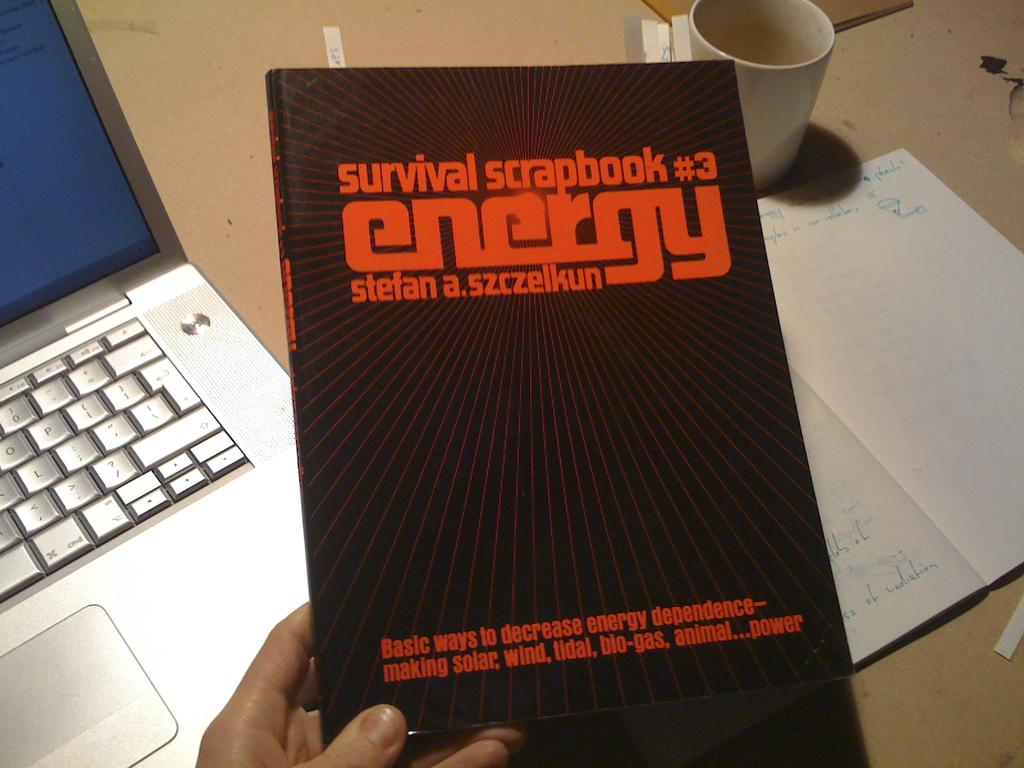Provide a one-sentence caption for the provided image. hand holding survival scrapbook #3 energy book with a laptop sitting on table below. 